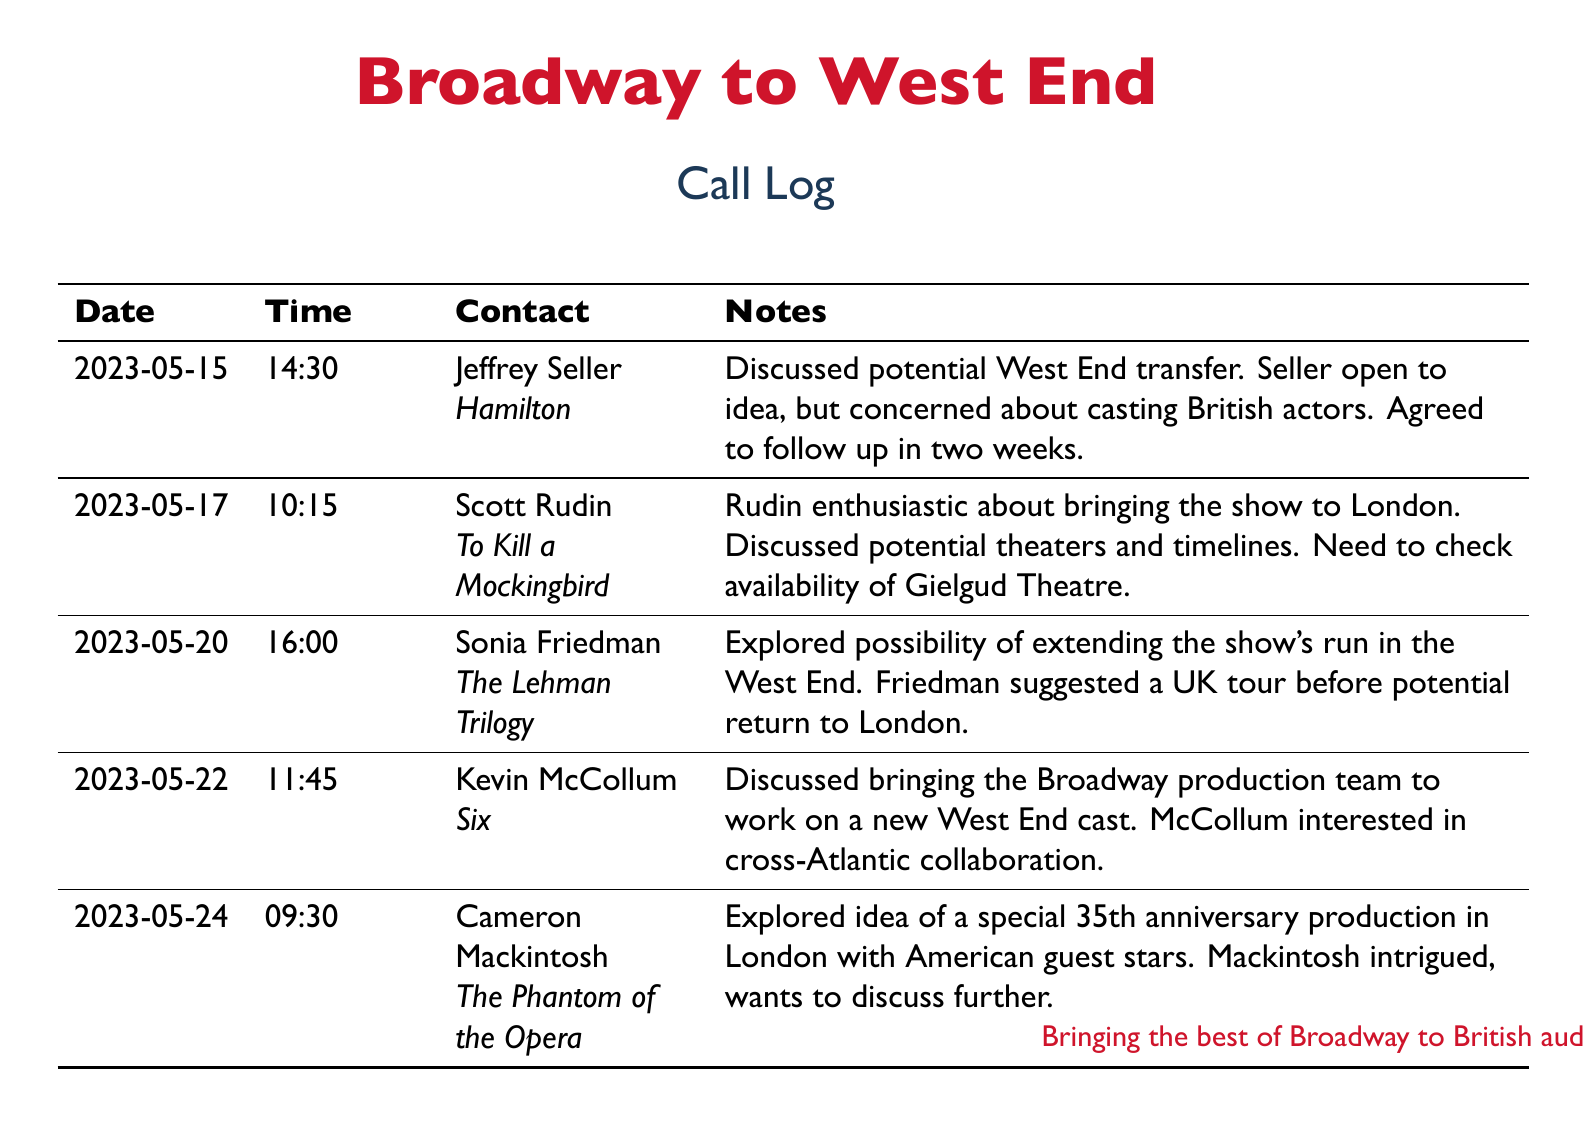What is the date of the conversation with Jeffrey Seller? The document lists the date of the conversation with Jeffrey Seller as May 15, 2023.
Answer: May 15, 2023 Who discussed the possibility of extending "The Lehman Trilogy" in the West End? The contact who discussed the possibility of extending "The Lehman Trilogy" was Sonia Friedman.
Answer: Sonia Friedman What show is Kevin McCollum associated with? The document indicates that Kevin McCollum is associated with the show "Six."
Answer: Six How did Scott Rudin feel about bringing his show to London? Scott Rudin was enthusiastic about bringing "To Kill a Mockingbird" to London.
Answer: Enthusiastic What was Cameron Mackintosh's proposal for "The Phantom of the Opera"? Cameron Mackintosh proposed a special 35th anniversary production in London with American guest stars.
Answer: Special 35th anniversary production What time did the call with Sonia Friedman take place? The call with Sonia Friedman occurred at 16:00.
Answer: 16:00 Who expressed interest in cross-Atlantic collaboration? Kevin McCollum expressed interest in cross-Atlantic collaboration.
Answer: Kevin McCollum What theater's availability needs to be checked for "To Kill a Mockingbird"? The availability of the Gielgud Theatre needs to be checked for "To Kill a Mockingbird."
Answer: Gielgud Theatre 